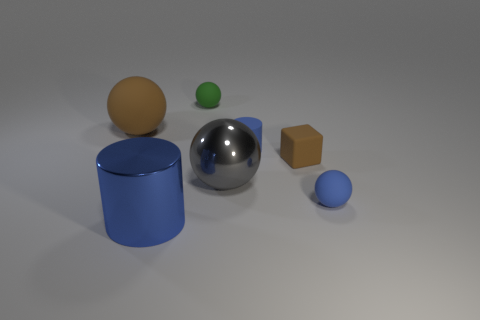What size is the other cylinder that is the same color as the large cylinder?
Ensure brevity in your answer.  Small. How big is the blue object in front of the tiny blue ball?
Ensure brevity in your answer.  Large. Is the size of the blue rubber cylinder the same as the brown object behind the blue rubber cylinder?
Ensure brevity in your answer.  No. Are there fewer big metal things left of the gray metal thing than large rubber balls?
Your answer should be compact. No. There is a large brown thing that is the same shape as the green rubber thing; what is it made of?
Keep it short and to the point. Rubber. What is the shape of the object that is to the left of the green rubber thing and in front of the big matte thing?
Your response must be concise. Cylinder. What shape is the large object that is made of the same material as the green sphere?
Your answer should be very brief. Sphere. There is a blue object that is on the right side of the matte cube; what material is it?
Your answer should be very brief. Rubber. There is a brown object on the right side of the big blue thing; does it have the same size as the cylinder behind the large metallic cylinder?
Your answer should be compact. Yes. What color is the shiny cylinder?
Make the answer very short. Blue. 